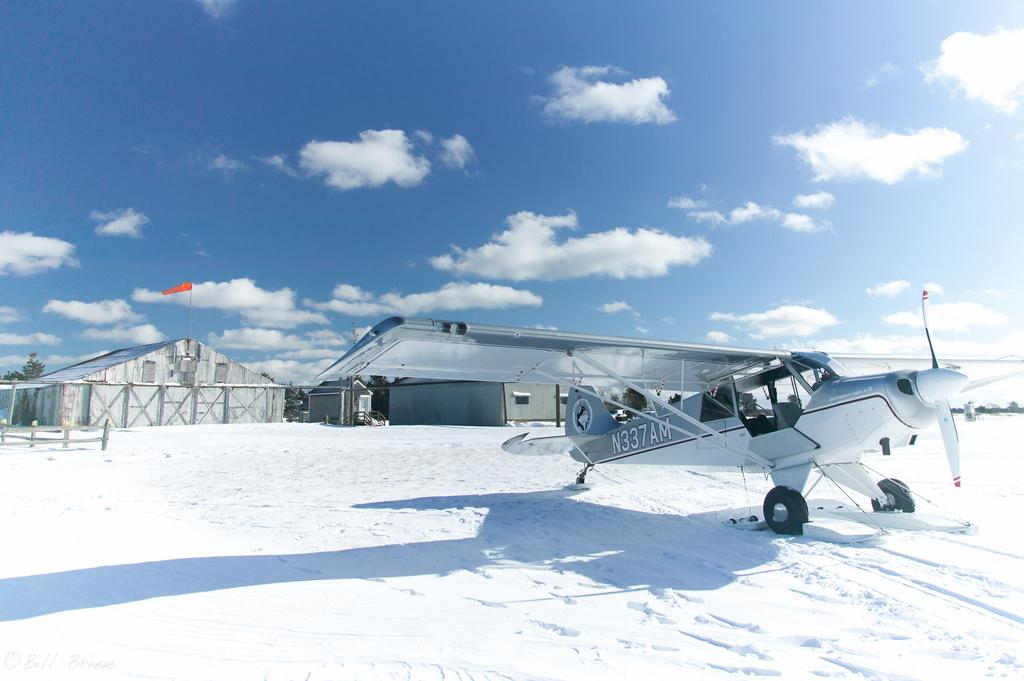<image>
Share a concise interpretation of the image provided. a plane with N337AM on the side of it 